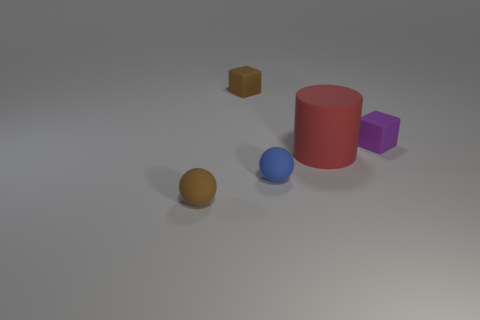Is there any other thing that is the same size as the red cylinder?
Ensure brevity in your answer.  No. There is a ball that is the same size as the blue matte object; what is its color?
Make the answer very short. Brown. Is the small object that is behind the purple rubber cube made of the same material as the small object that is to the right of the big matte thing?
Your answer should be compact. Yes. How big is the rubber cylinder that is in front of the small brown object behind the red matte cylinder?
Provide a succinct answer. Large. There is a block that is right of the large red cylinder; what is it made of?
Your answer should be very brief. Rubber. How many objects are either tiny cubes to the right of the red cylinder or matte objects that are in front of the large rubber object?
Provide a succinct answer. 3. There is a brown thing that is the same shape as the purple object; what material is it?
Your answer should be compact. Rubber. There is a small cube that is to the left of the big red matte cylinder; is it the same color as the tiny rubber thing in front of the blue matte object?
Your answer should be compact. Yes. Are there any brown cubes that have the same size as the purple rubber cube?
Make the answer very short. Yes. What is the object that is left of the red object and behind the small blue rubber sphere made of?
Give a very brief answer. Rubber. 